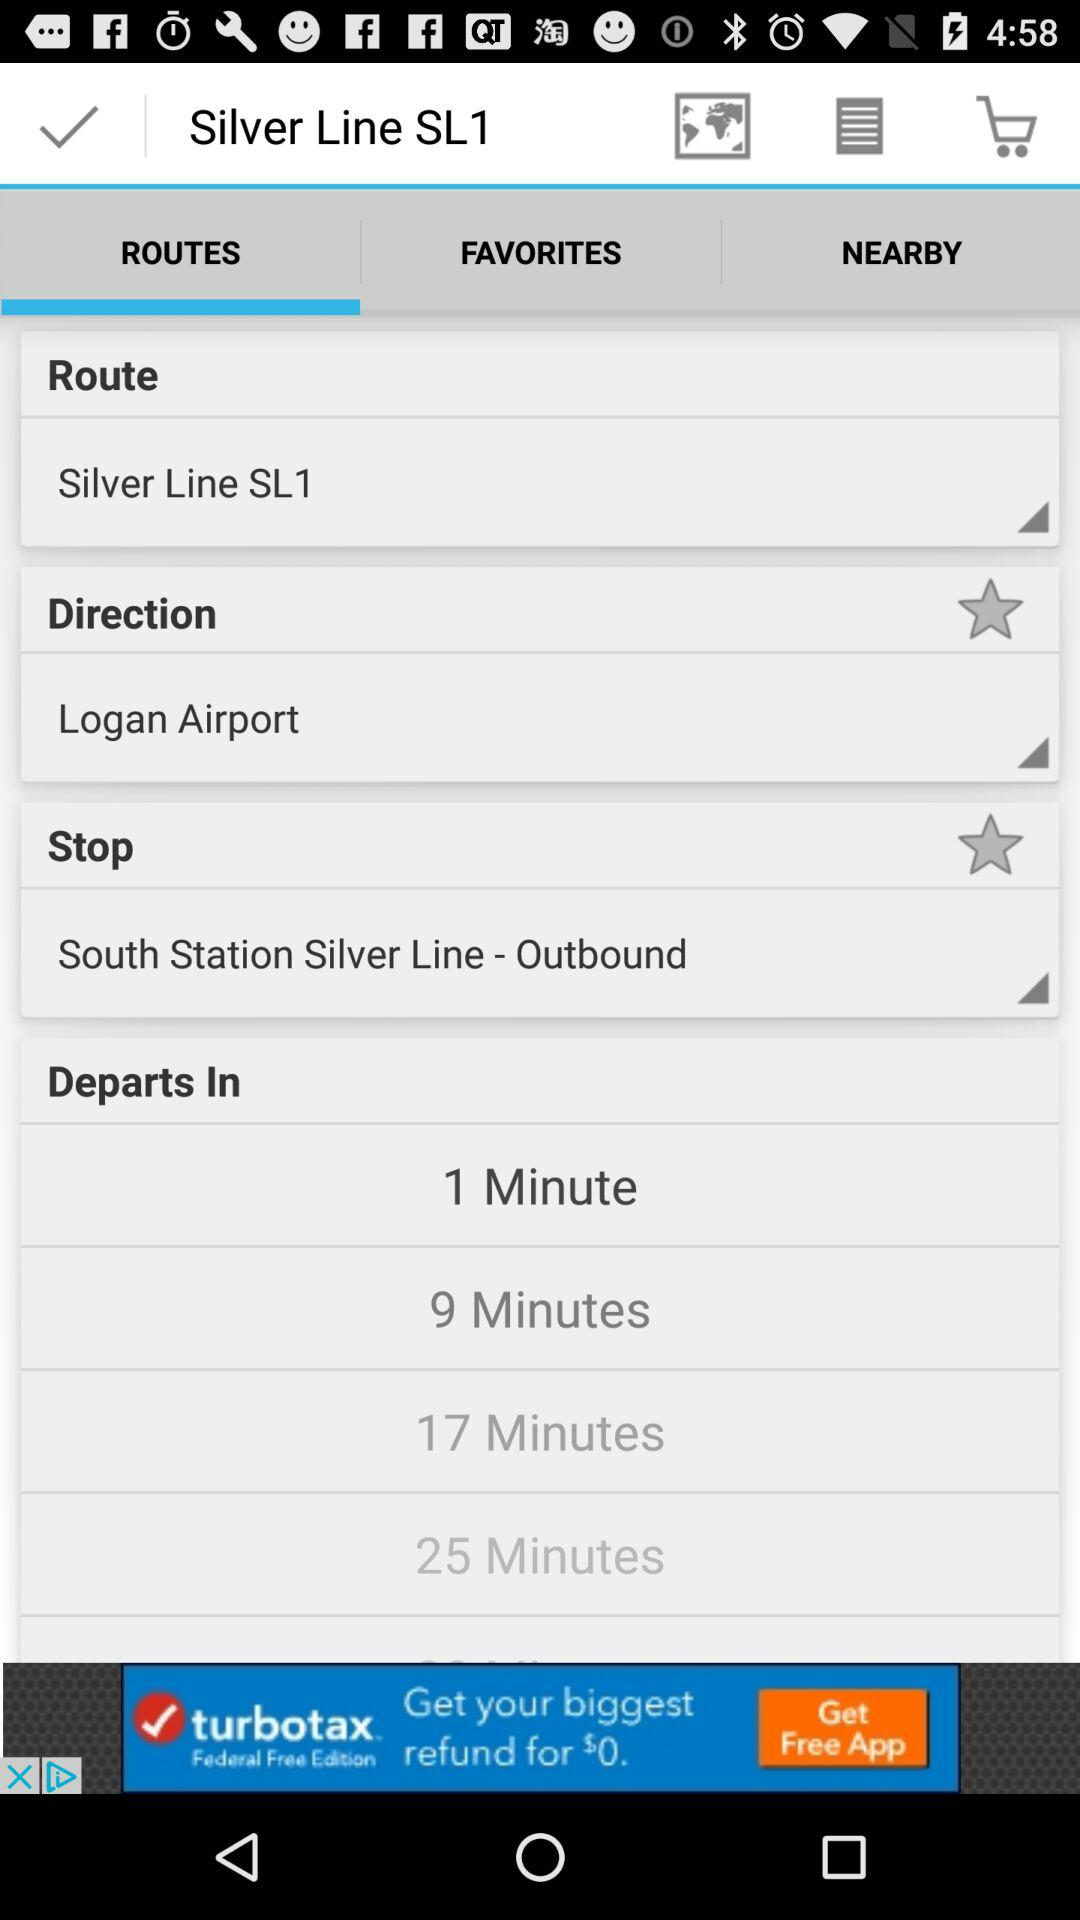Which route is chosen? The chosen route is "Silver Line SL1". 